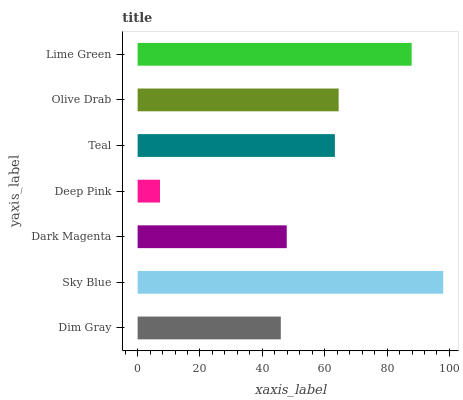Is Deep Pink the minimum?
Answer yes or no. Yes. Is Sky Blue the maximum?
Answer yes or no. Yes. Is Dark Magenta the minimum?
Answer yes or no. No. Is Dark Magenta the maximum?
Answer yes or no. No. Is Sky Blue greater than Dark Magenta?
Answer yes or no. Yes. Is Dark Magenta less than Sky Blue?
Answer yes or no. Yes. Is Dark Magenta greater than Sky Blue?
Answer yes or no. No. Is Sky Blue less than Dark Magenta?
Answer yes or no. No. Is Teal the high median?
Answer yes or no. Yes. Is Teal the low median?
Answer yes or no. Yes. Is Lime Green the high median?
Answer yes or no. No. Is Lime Green the low median?
Answer yes or no. No. 